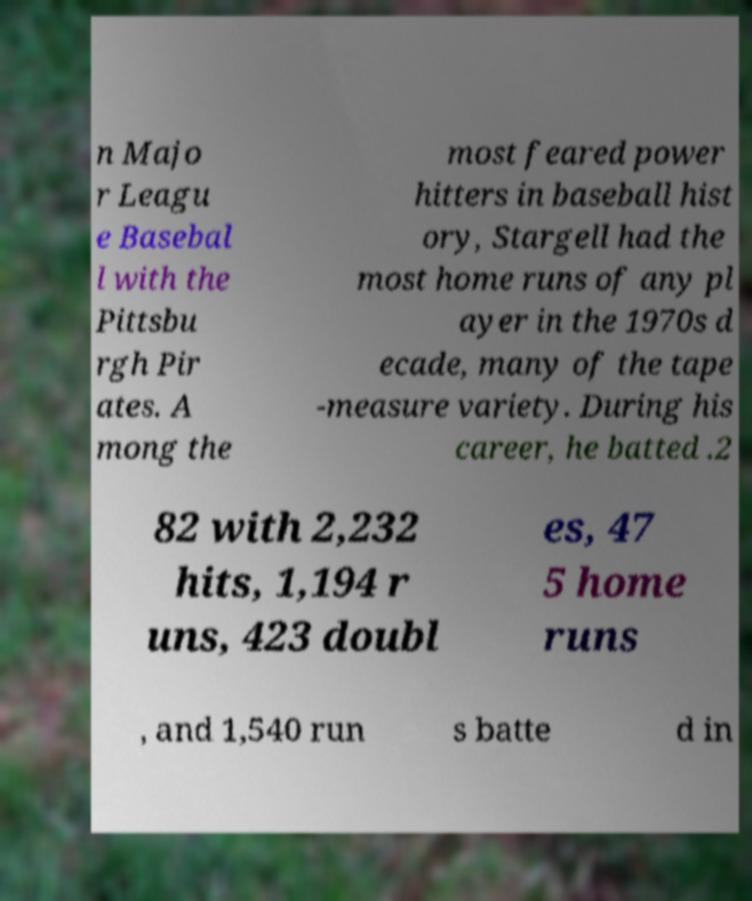There's text embedded in this image that I need extracted. Can you transcribe it verbatim? n Majo r Leagu e Basebal l with the Pittsbu rgh Pir ates. A mong the most feared power hitters in baseball hist ory, Stargell had the most home runs of any pl ayer in the 1970s d ecade, many of the tape -measure variety. During his career, he batted .2 82 with 2,232 hits, 1,194 r uns, 423 doubl es, 47 5 home runs , and 1,540 run s batte d in 